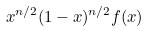Convert formula to latex. <formula><loc_0><loc_0><loc_500><loc_500>x ^ { n / 2 } ( 1 - x ) ^ { n / 2 } f ( x )</formula> 